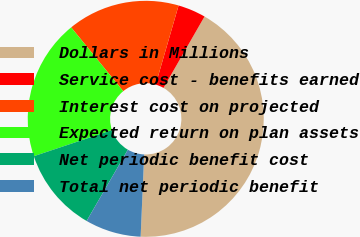<chart> <loc_0><loc_0><loc_500><loc_500><pie_chart><fcel>Dollars in Millions<fcel>Service cost - benefits earned<fcel>Interest cost on projected<fcel>Expected return on plan assets<fcel>Net periodic benefit cost<fcel>Total net periodic benefit<nl><fcel>42.39%<fcel>3.81%<fcel>15.38%<fcel>19.24%<fcel>11.52%<fcel>7.66%<nl></chart> 